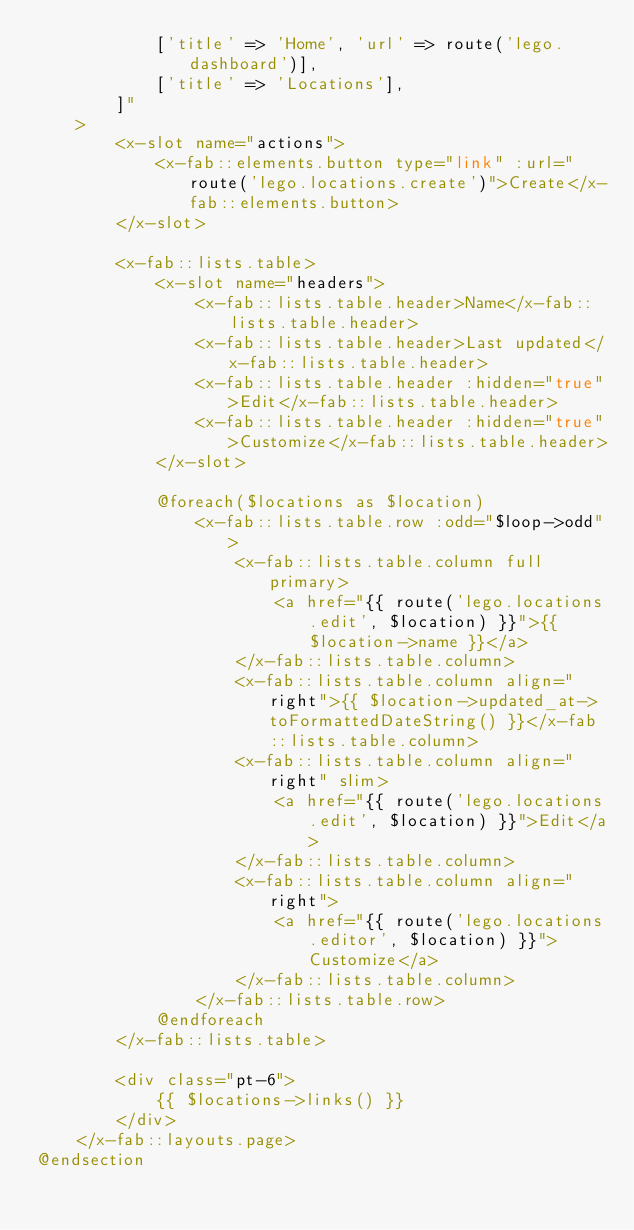Convert code to text. <code><loc_0><loc_0><loc_500><loc_500><_PHP_>            ['title' => 'Home', 'url' => route('lego.dashboard')],
            ['title' => 'Locations'],
        ]"
    >
        <x-slot name="actions">
            <x-fab::elements.button type="link" :url="route('lego.locations.create')">Create</x-fab::elements.button>
        </x-slot>

        <x-fab::lists.table>
            <x-slot name="headers">
                <x-fab::lists.table.header>Name</x-fab::lists.table.header>
                <x-fab::lists.table.header>Last updated</x-fab::lists.table.header>
                <x-fab::lists.table.header :hidden="true">Edit</x-fab::lists.table.header>
                <x-fab::lists.table.header :hidden="true">Customize</x-fab::lists.table.header>
            </x-slot>

            @foreach($locations as $location)
                <x-fab::lists.table.row :odd="$loop->odd">
                    <x-fab::lists.table.column full primary>
                        <a href="{{ route('lego.locations.edit', $location) }}">{{ $location->name }}</a>
                    </x-fab::lists.table.column>
                    <x-fab::lists.table.column align="right">{{ $location->updated_at->toFormattedDateString() }}</x-fab::lists.table.column>
                    <x-fab::lists.table.column align="right" slim>
                        <a href="{{ route('lego.locations.edit', $location) }}">Edit</a>
                    </x-fab::lists.table.column>
                    <x-fab::lists.table.column align="right">
                        <a href="{{ route('lego.locations.editor', $location) }}">Customize</a>
                    </x-fab::lists.table.column>
                </x-fab::lists.table.row>
            @endforeach
        </x-fab::lists.table>

        <div class="pt-6">
            {{ $locations->links() }}
        </div>
    </x-fab::layouts.page>
@endsection
</code> 